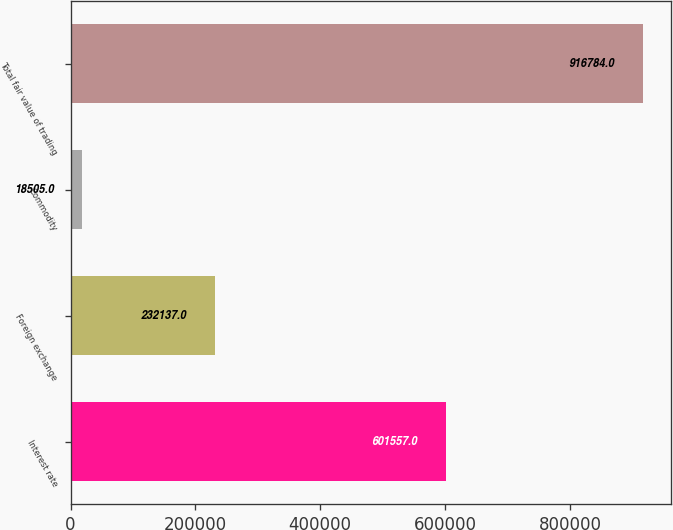Convert chart to OTSL. <chart><loc_0><loc_0><loc_500><loc_500><bar_chart><fcel>Interest rate<fcel>Foreign exchange<fcel>Commodity<fcel>Total fair value of trading<nl><fcel>601557<fcel>232137<fcel>18505<fcel>916784<nl></chart> 